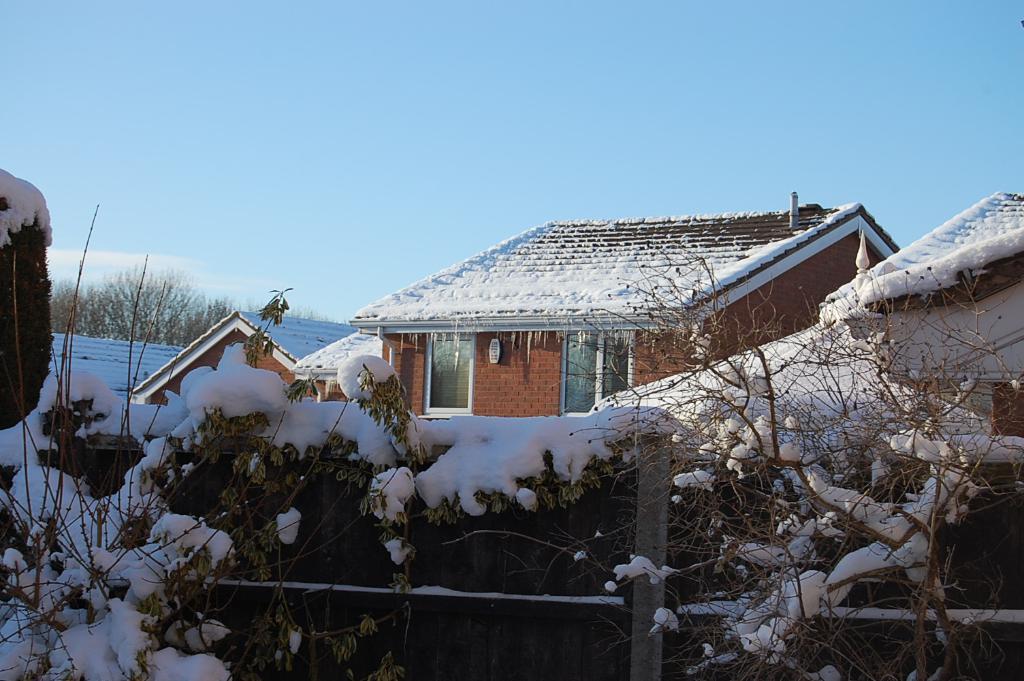In one or two sentences, can you explain what this image depicts? In this image we can see houses. On the houses we can see the snow. In the foreground we can see fencing, plants and snow. Behind the houses we can see the trees. At the top we can see the sky. 